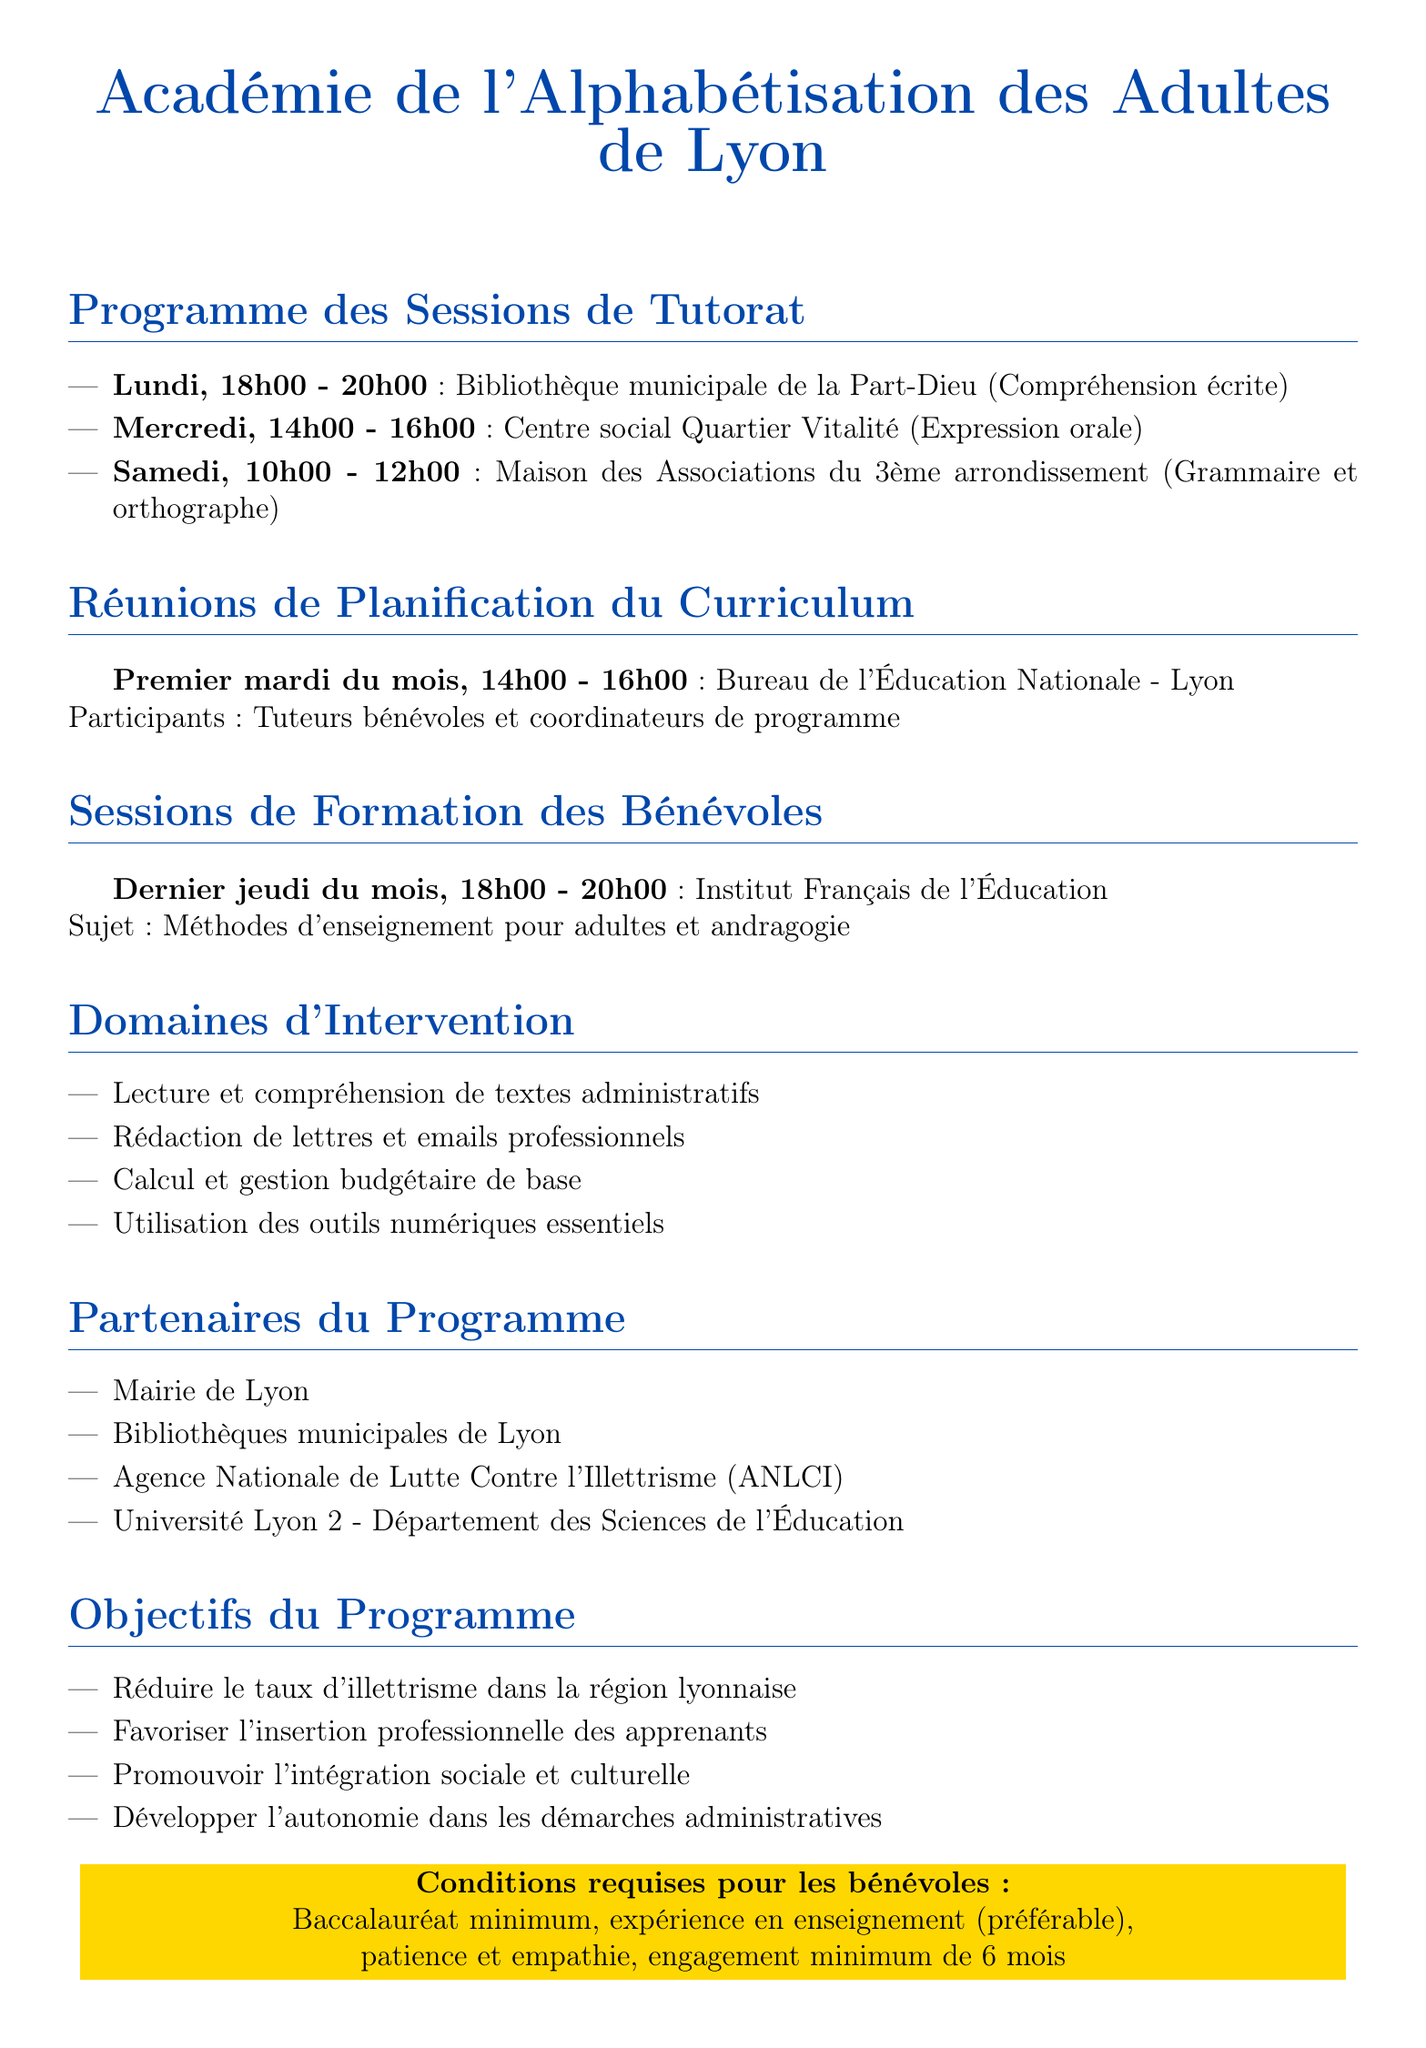Quel est le nom du programme ? Le nom du programme est mentionné en haut du document.
Answer: Académie de l'Alphabétisation des Adultes de Lyon Quels jours ont lieu les sessions de tutorat ? Les jours des sessions de tutorat sont listés dans la section des sessions de tutorat.
Answer: Lundi, Mercredi, Samedi Quel est le sujet de la session de formation des bénévoles ? Le sujet de la session de formation des bénévoles est indiqué dans la section correspondante.
Answer: Méthodes d'enseignement pour adultes et andragogie Qui sont les partenaires du programme ? Les partenaires du programme sont énumérés dans la section des partenaires du programme.
Answer: Mairie de Lyon, Bibliothèques municipales de Lyon, Agence Nationale de Lutte Contre l'Illettrisme (ANLCI), Université Lyon 2 - Département des Sciences de l'Éducation Combien de temps d'engagement est requis pour les bénévoles ? La durée d'engagement requise est mentionnée dans la section des conditions pour les bénévoles.
Answer: 6 mois Quelle est l'heure de la réunion de planification du curriculum ? L'heure de la réunion de planification du curriculum est spécifiée dans la section des réunions de planification.
Answer: 14h00 - 16h00 Quel est l'objectif principal du programme ? Un des objectifs principaux du programme est détaillé dans la section des objectifs du programme.
Answer: Réduire le taux d'illettrisme dans la région lyonnaise 